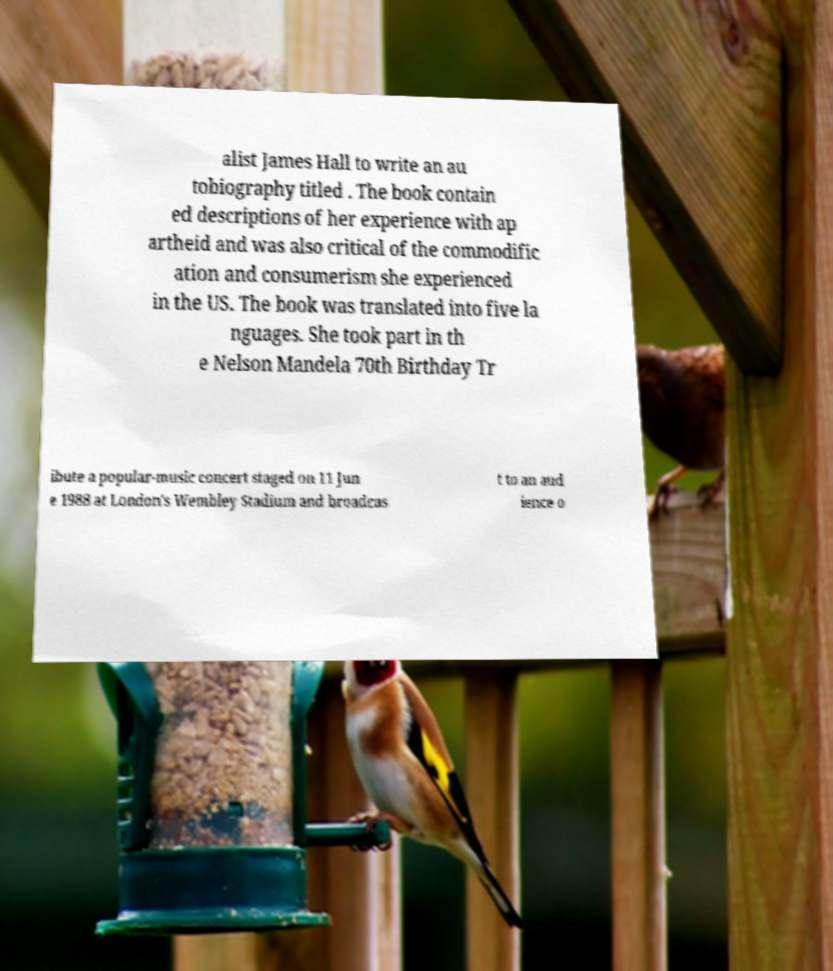I need the written content from this picture converted into text. Can you do that? alist James Hall to write an au tobiography titled . The book contain ed descriptions of her experience with ap artheid and was also critical of the commodific ation and consumerism she experienced in the US. The book was translated into five la nguages. She took part in th e Nelson Mandela 70th Birthday Tr ibute a popular-music concert staged on 11 Jun e 1988 at London's Wembley Stadium and broadcas t to an aud ience o 